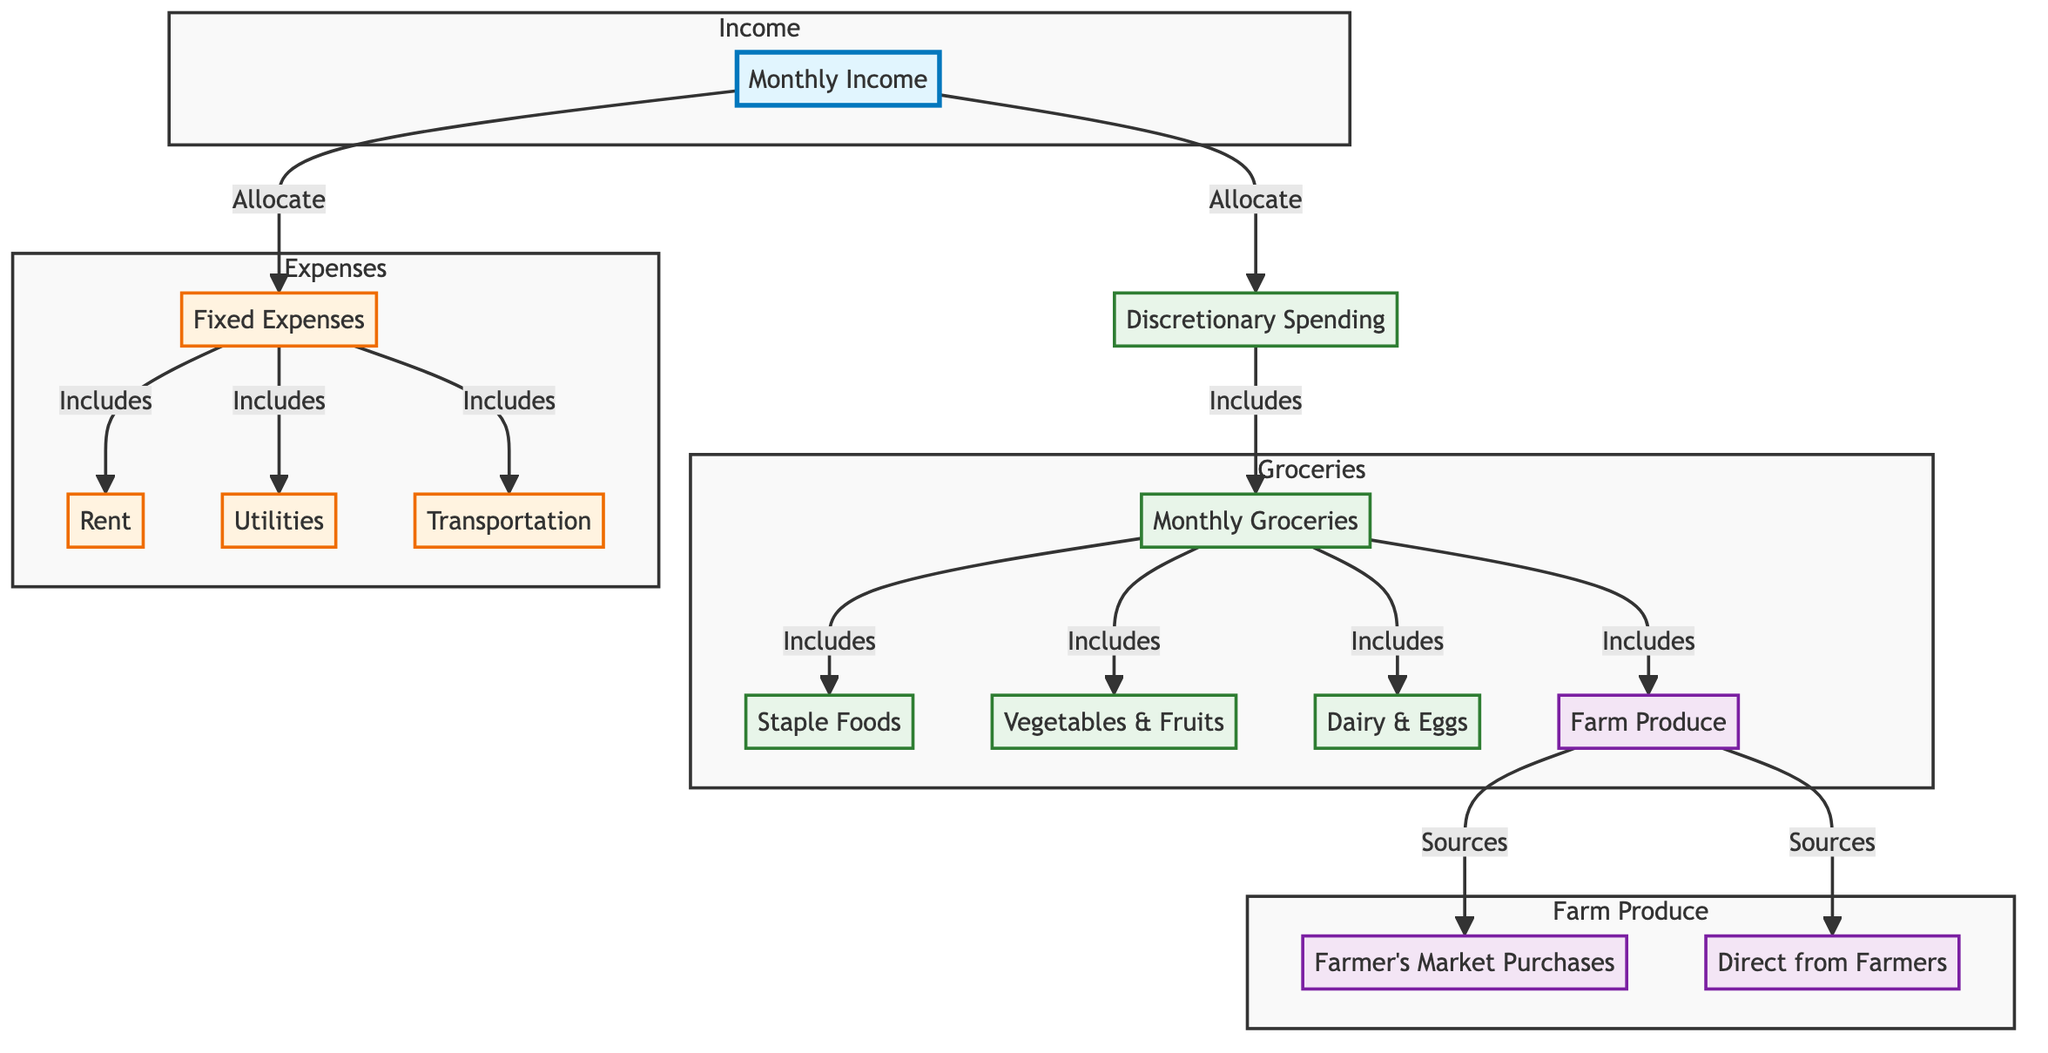What is the main source of input in the diagram? The main source of input in the diagram is the "Monthly Income," which serves as the starting point for budget allocation.
Answer: Monthly Income How many categories are under Fixed Expenses? The fixed expenses category includes three distinct components: Rent, Utilities, and Transportation.
Answer: 3 Which categories are included under Monthly Groceries? The Monthly Groceries category includes Staple Foods, Vegetables & Fruits, Dairy & Eggs, and Farm Produce.
Answer: Staple Foods, Vegetables & Fruits, Dairy & Eggs, Farm Produce What are the sources of Farm Produce mentioned in the diagram? The sources of Farm Produce are specified in the diagram as Farmer's Market Purchases and Direct from Farmers.
Answer: Farmer's Market Purchases, Direct from Farmers How does Monthly Income relate to Discretionary Spending? Monthly Income allocates a portion of itself to Discretionary Spending, indicating that it's directly sourced from the total income as part of budget allocation.
Answer: Allocates What is the relationship between Groceries and Farm Produce? Groceries includes Farm Produce, which indicates that it is a part of the overall grocery budget.
Answer: Includes How many components fall under the category of Discretionary Spending? There is only one component specified under Discretionary Spending, which is Monthly Groceries.
Answer: 1 If Fixed Expenses include Rent, what other components are there? Besides Rent, the Fixed Expenses also include Utilities and Transportation, showing they are all part of the fixed costs.
Answer: Utilities, Transportation What type of diagram is used to represent the budget allocation? The type of diagram used here is a flowchart, which effectively visualizes the relationships and allocations within the budget.
Answer: Flowchart 